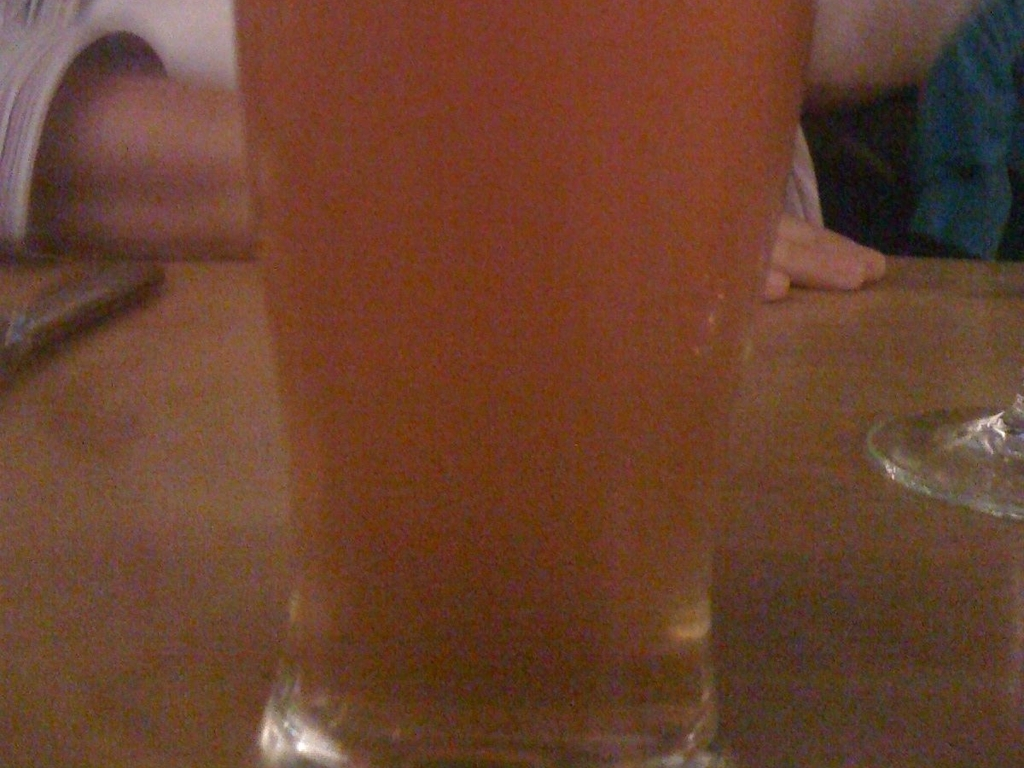What kind of drink is displayed in the image? The image features a glass which appears to contain a hazy amber liquid, likely a type of beer, though the specific variety cannot be determined from the image alone. 